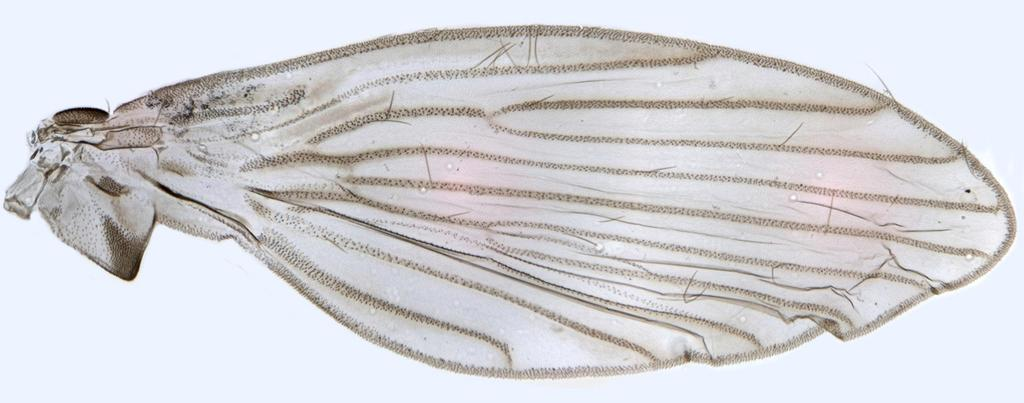What is the main subject of the image? The main subject of the image is a wing of an insect. What color is the background of the image? The background of the image is white in color. What type of food is being prepared in the image? There is no food present in the image; it features a wing of an insect and a white background. What kind of game is being played in the image? There is no game being played in the image; it features a wing of an insect and a white background. 